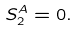Convert formula to latex. <formula><loc_0><loc_0><loc_500><loc_500>S _ { 2 } ^ { A } = 0 .</formula> 